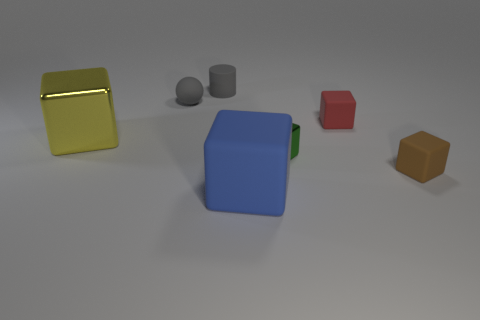There is a ball that is the same color as the tiny matte cylinder; what is its size?
Offer a terse response. Small. Is there a block that has the same color as the small rubber cylinder?
Your response must be concise. No. There is a matte ball that is the same size as the brown matte block; what color is it?
Your response must be concise. Gray. There is a large object in front of the tiny brown rubber cube; is there a large blue rubber thing behind it?
Provide a succinct answer. No. What is the material of the cube behind the large yellow thing?
Your response must be concise. Rubber. Is the big thing in front of the brown matte object made of the same material as the tiny object on the left side of the gray matte cylinder?
Offer a very short reply. Yes. Are there the same number of rubber spheres that are on the right side of the small brown matte cube and rubber things in front of the tiny cylinder?
Offer a terse response. No. How many other cubes are made of the same material as the small red block?
Your answer should be very brief. 2. There is a matte thing that is the same color as the matte cylinder; what shape is it?
Ensure brevity in your answer.  Sphere. What is the size of the metal block left of the large thing in front of the green metallic thing?
Make the answer very short. Large. 